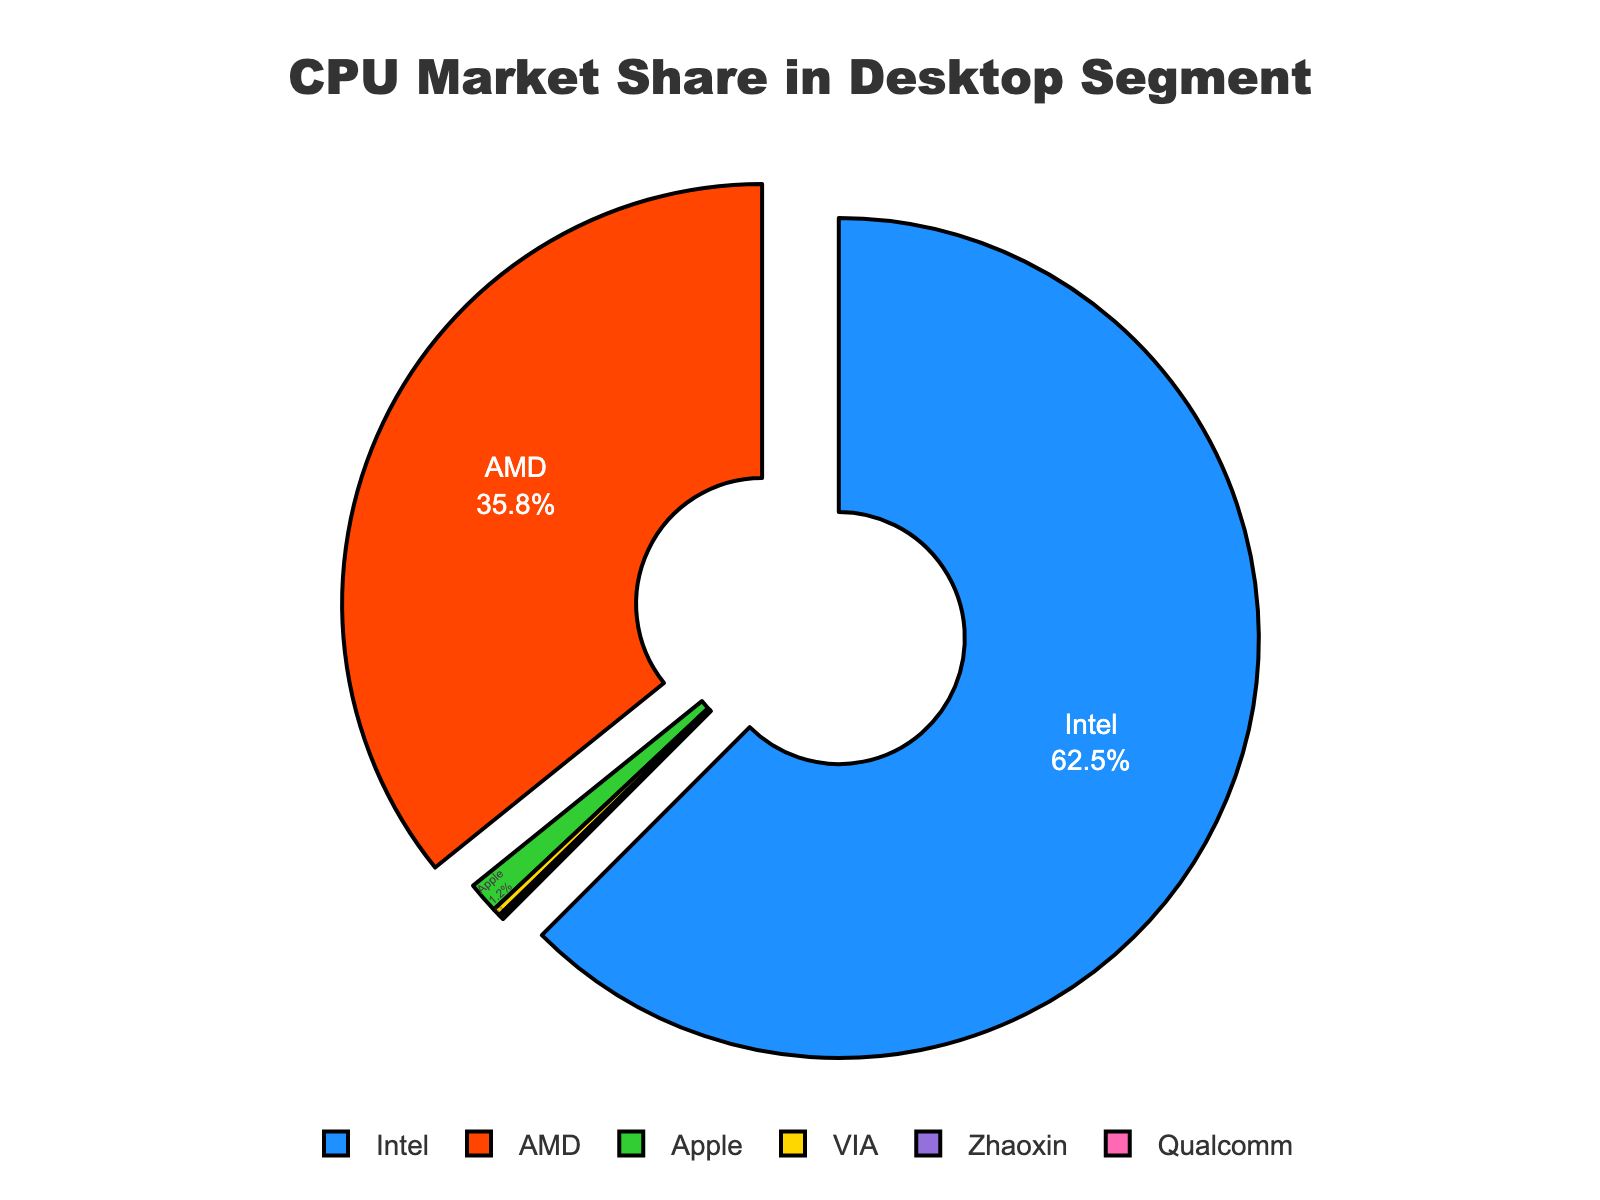What's the market share of the leading CPU manufacturer in the desktop segment? The largest portion of the pie chart, colored in blue, represents Intel, which has the highest market share. The text inside the chart indicates Intel has 62.5%.
Answer: 62.5% How much greater is Intel's market share compared to AMD's? Intel's market share is 62.5% and AMD's is 35.8%. Subtracting AMD's share from Intel's share gives 62.5% - 35.8% = 26.7%.
Answer: 26.7% What is the combined market share of the three smallest manufacturers? The market shares of Apple, VIA, Zhaoxin, and Qualcomm are 1.2%, 0.3%, 0.1%, and 0.1% respectively. Adding these gives 1.2 + 0.3 + 0.1 + 0.1 = 1.7%.
Answer: 1.7% Which manufacturers have a market share smaller than 1%? The text inside the chart shows that VIA, Zhaoxin, and Qualcomm each have market shares of 0.3%, 0.1%, and 0.1% respectively, all smaller than 1%.
Answer: VIA, Zhaoxin, Qualcomm What visual elements distinguish the two manufacturers with the largest shares? The two largest shares, blue and orange, are pulled out from the rest of the pie chart, indicating emphasis. These correspond to Intel and AMD. The pulling indicates a visual distinction for focus.
Answer: Pulled out segments for Intel and AMD Which manufacturer is represented by the green segment on the pie chart? The green segment, according to the color coding in the visualization, represents Apple.
Answer: Apple What is the difference in market share between the smallest and the largest manufacturers? The largest manufacturer, Intel, has a 62.5% market share, and the smallest ones, Zhaoxin and Qualcomm, each have a 0.1% share. The difference is 62.5% - 0.1% = 62.4%.
Answer: 62.4% Which manufacturer holds a market share of 0.3% and how is it visually indicated on the chart? From the text labels on the chart, the manufacturer with a 0.3% market share is VIA. It is colored in yellow.
Answer: VIA What's the total market share of manufacturers other than Intel and AMD? Adding the market shares of Apple (1.2%), VIA (0.3%), Zhaoxin (0.1%), and Qualcomm (0.1%) results in a total of 1.7%.
Answer: 1.7% What percentage of the pie chart does the smallest sector represent? The segments representing Zhaoxin and Qualcomm are the smallest, each with a 0.1% share.
Answer: 0.1% 